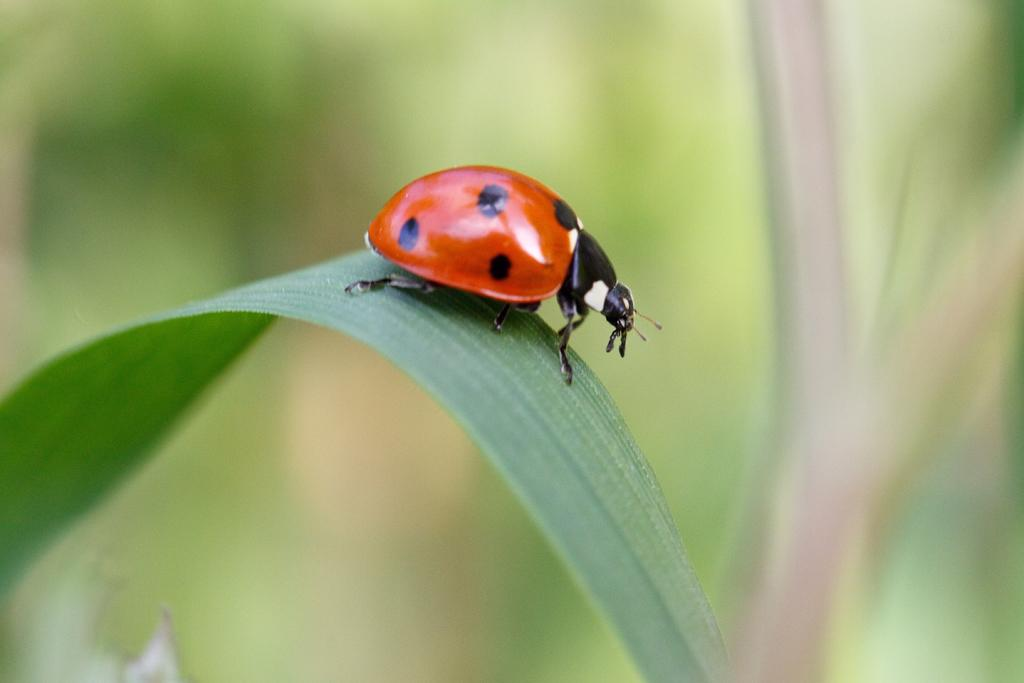What is the main subject of the image? There is a bug on a leaf in the image. Can you describe the background of the image? The background of the image is blurred. What type of spacecraft can be seen in the background of the image? There is no spacecraft present in the image; the background is blurred and does not show any space-related objects. What authority figure is depicted in the image? There is no authority figure present in the image; it features a bug on a leaf with a blurred background. 